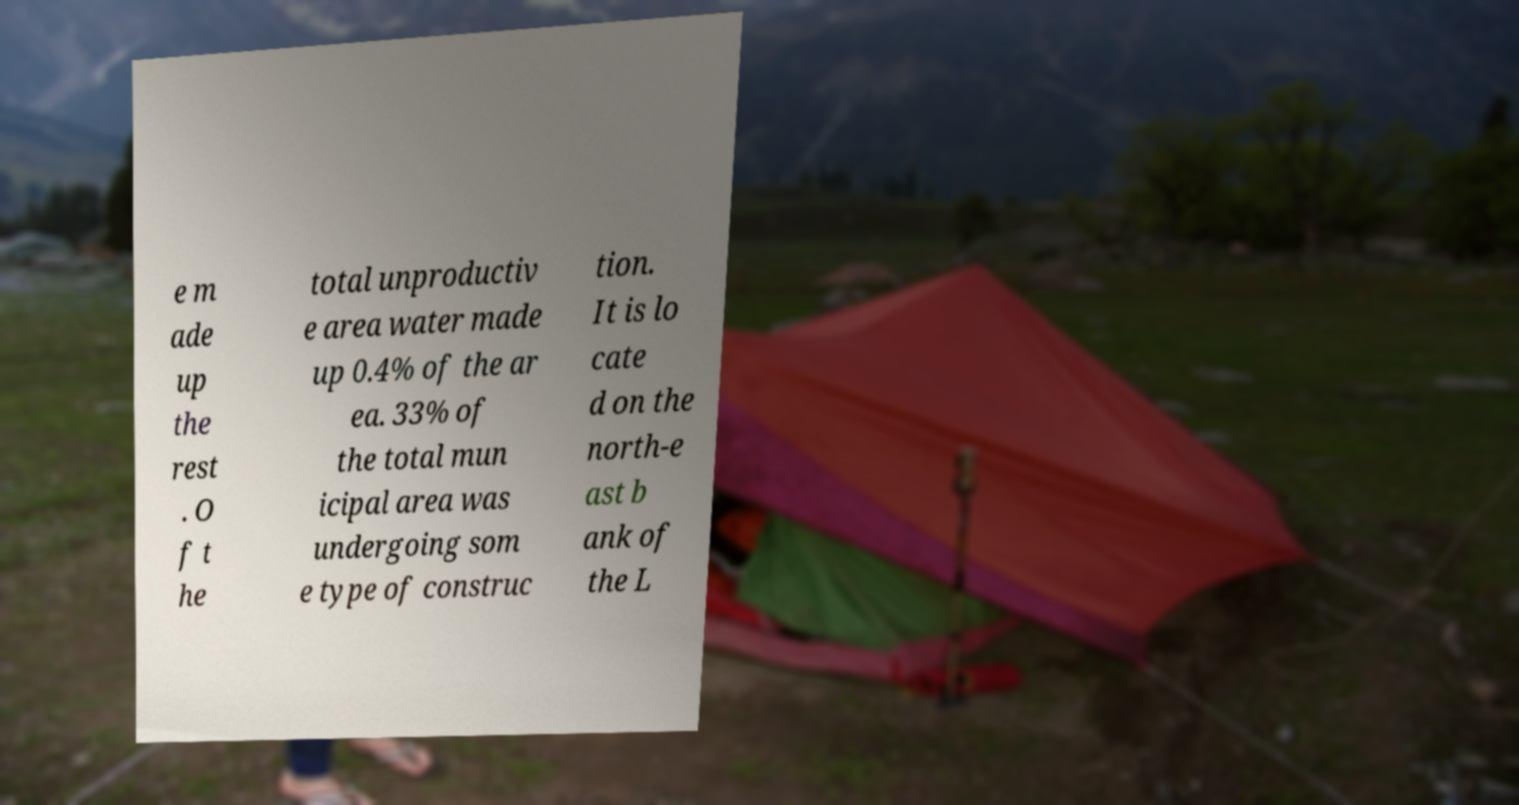Please identify and transcribe the text found in this image. e m ade up the rest . O f t he total unproductiv e area water made up 0.4% of the ar ea. 33% of the total mun icipal area was undergoing som e type of construc tion. It is lo cate d on the north-e ast b ank of the L 